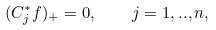<formula> <loc_0><loc_0><loc_500><loc_500>( C _ { j } ^ { * } f ) _ { + } = 0 , \quad j = 1 , . . , n ,</formula> 